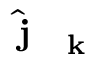<formula> <loc_0><loc_0><loc_500><loc_500>\hat { j } _ { k }</formula> 